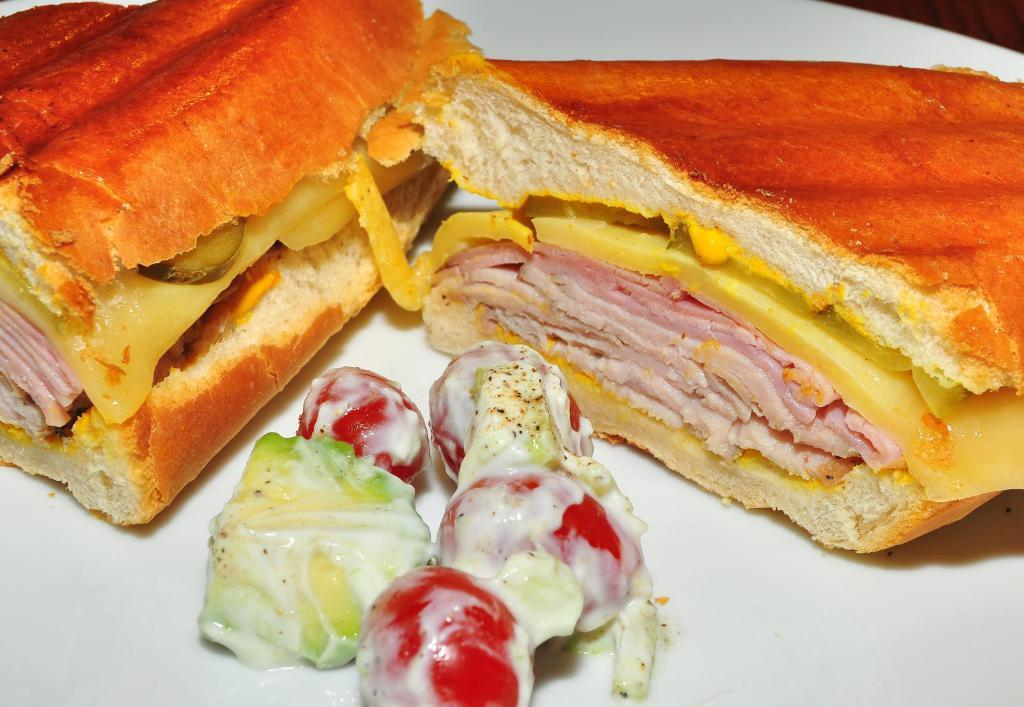What is on the plate that is visible in the image? There is a plate of food items in the image. Where is the plate located in the image? The plate is on a wooden surface. How many babies are holding onto the plate in the image? There are no babies present in the image, and therefore none are holding onto the plate. 